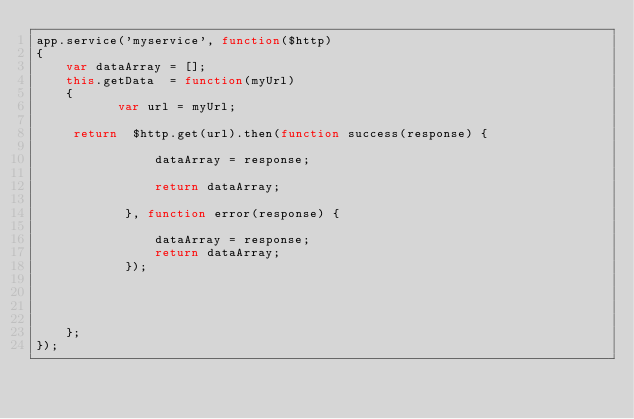<code> <loc_0><loc_0><loc_500><loc_500><_JavaScript_>app.service('myservice', function($http) 
{ 
	var dataArray = []; 
    this.getData  = function(myUrl) 
    { 
           var url = myUrl;
          
     return  $http.get(url).then(function success(response) {

				dataArray = response;

				return dataArray;	

			}, function error(response) {

				dataArray = response;
				return dataArray;
			});


          
          
    }; 
});
</code> 